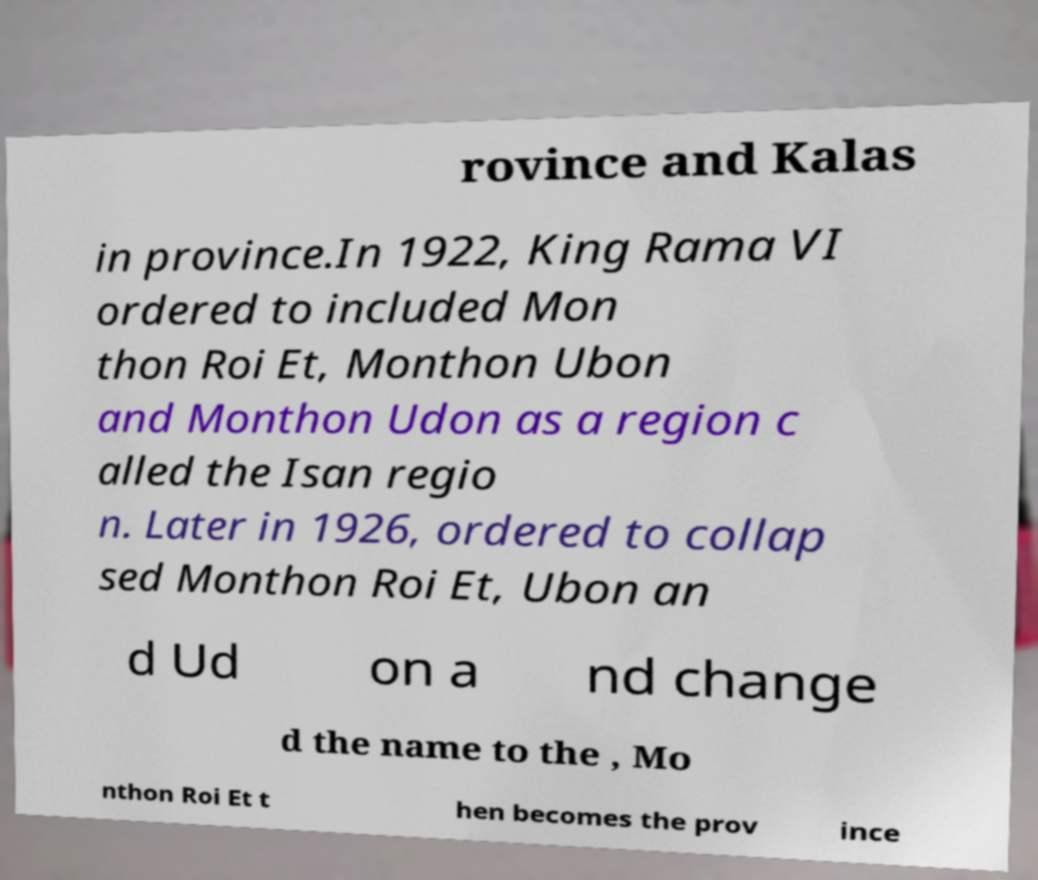Could you extract and type out the text from this image? rovince and Kalas in province.In 1922, King Rama VI ordered to included Mon thon Roi Et, Monthon Ubon and Monthon Udon as a region c alled the Isan regio n. Later in 1926, ordered to collap sed Monthon Roi Et, Ubon an d Ud on a nd change d the name to the , Mo nthon Roi Et t hen becomes the prov ince 